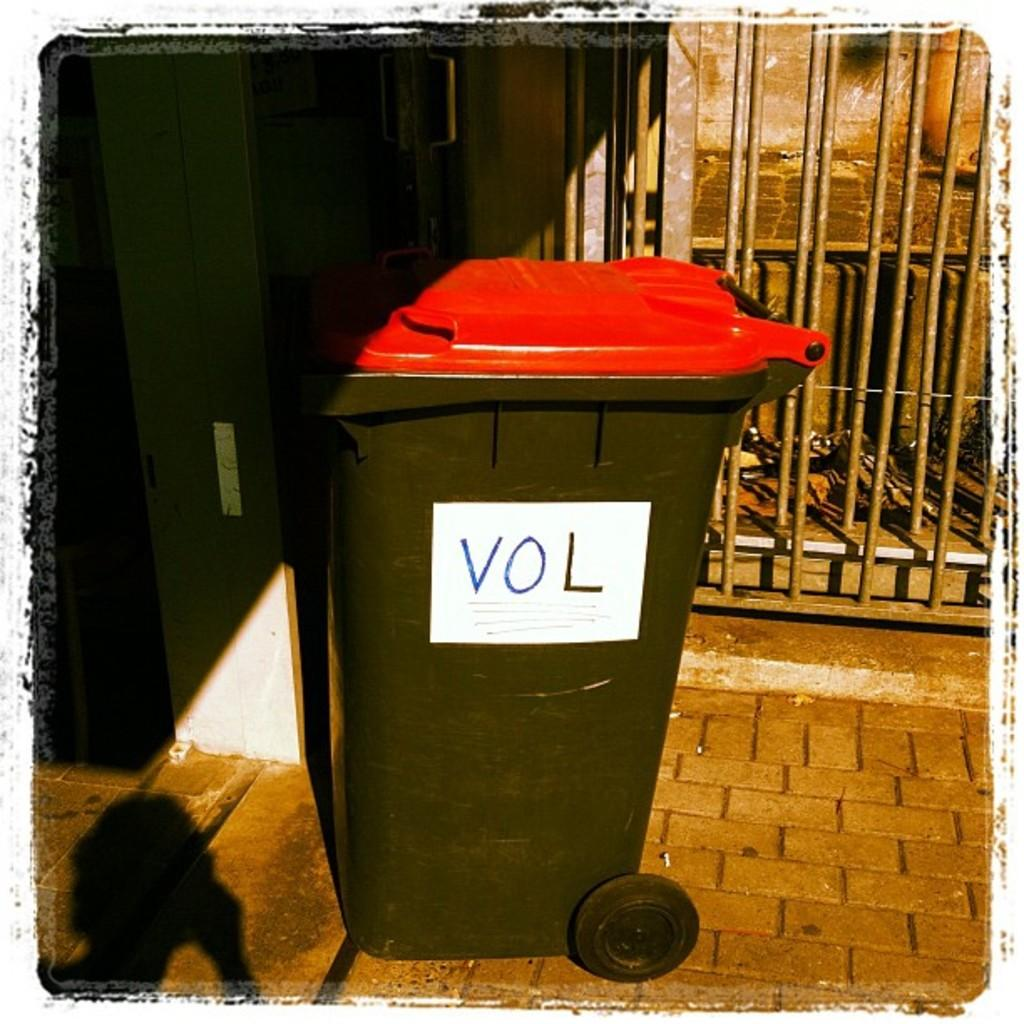<image>
Give a short and clear explanation of the subsequent image. a red and black trash can with the letters vol on it 